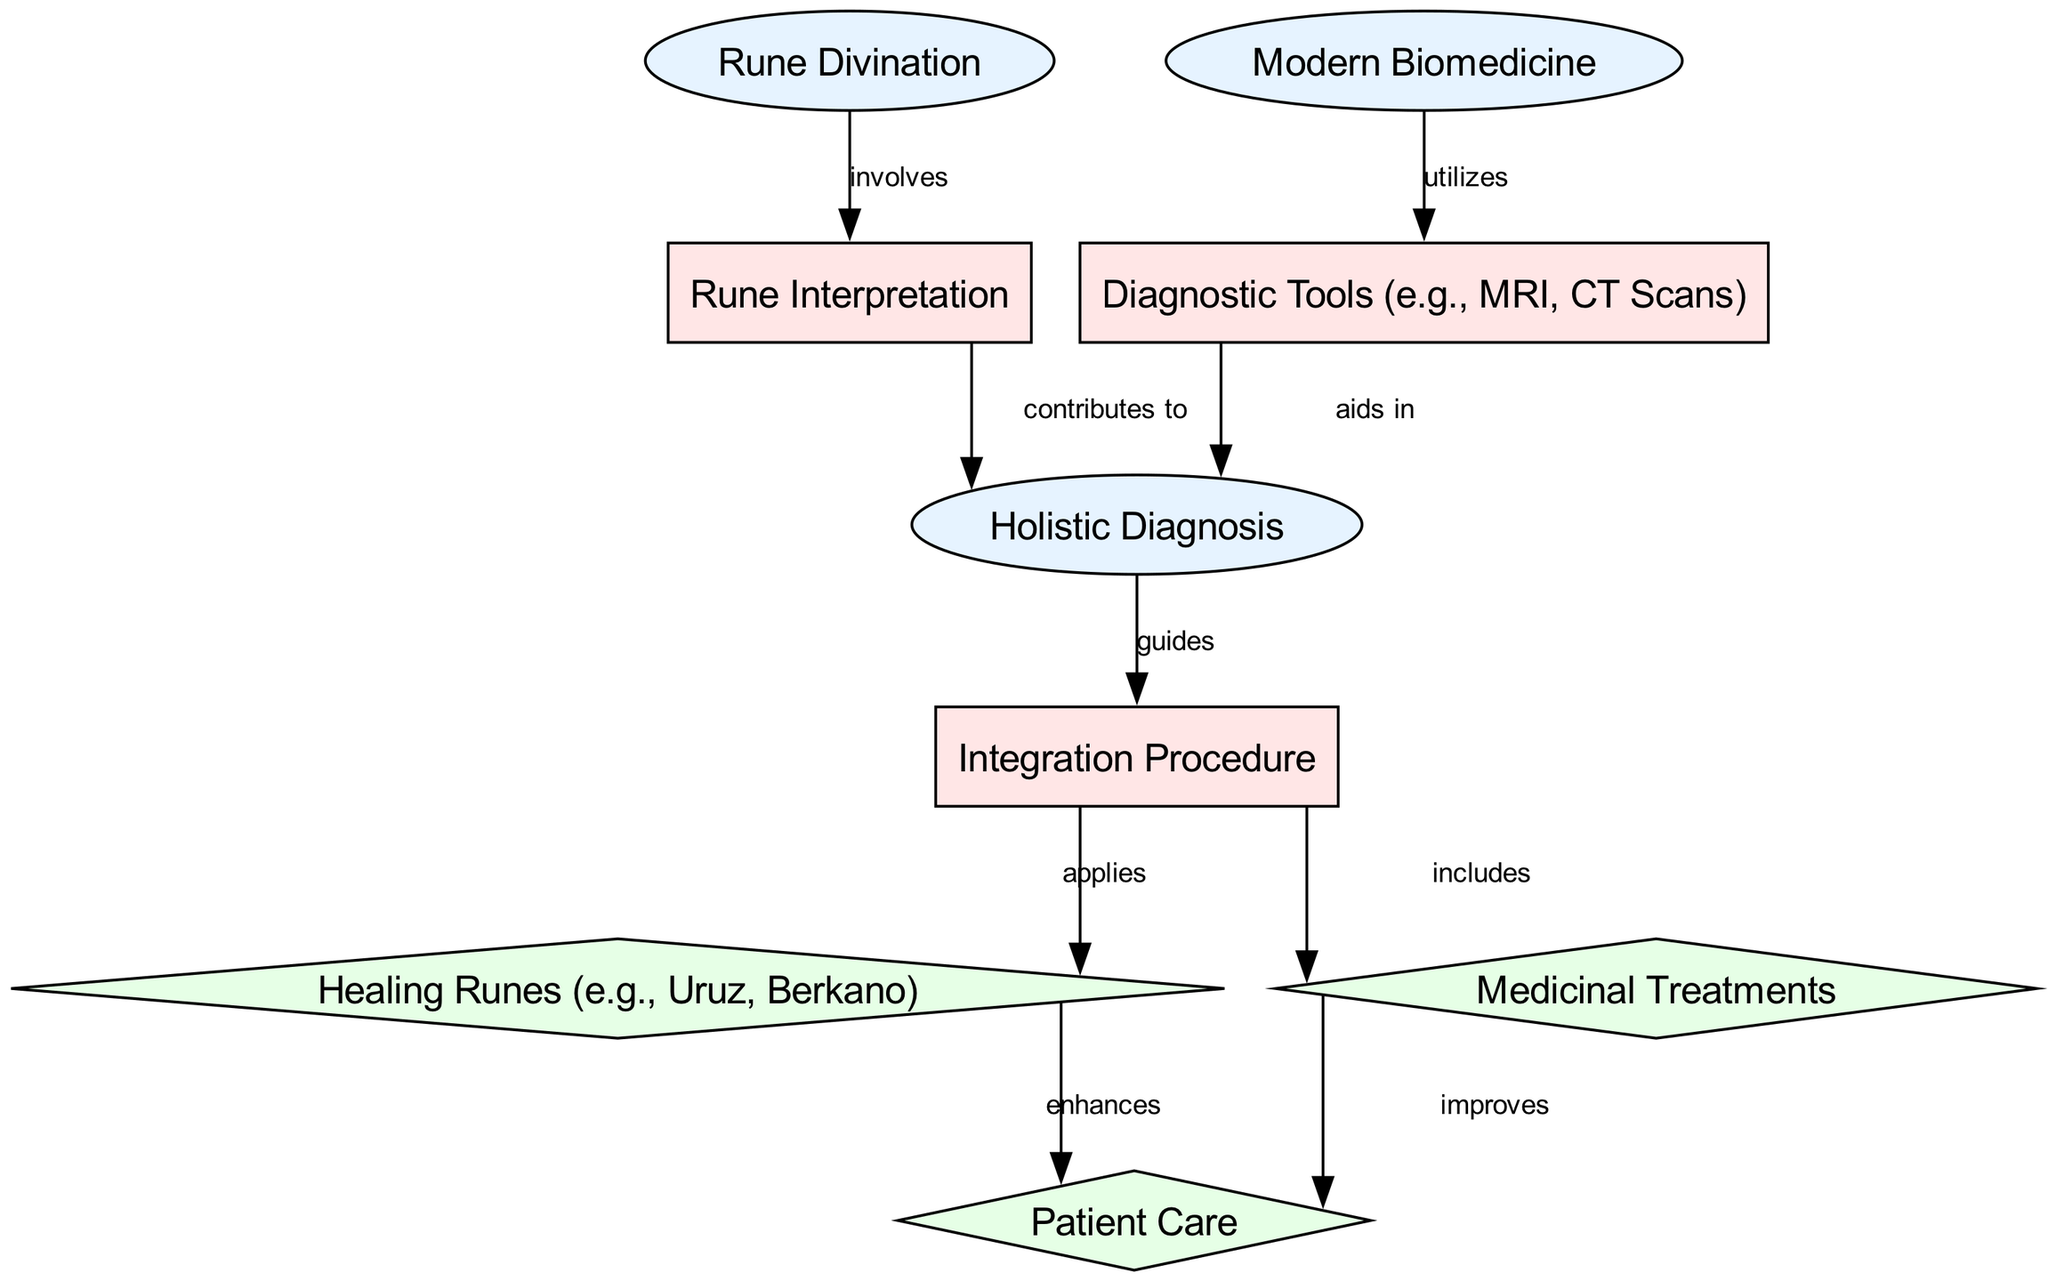What is the first process listed in the diagram? The first process in the diagram is 'Rune Interpretation', which is directly connected to 'Rune Divination'. We identify this by assessing the flow from the initial node connected by the edge labeled "involves".
Answer: Rune Interpretation How many outcomes are shown in the diagram? There are three outcomes depicted in the diagram: 'Healing Runes', 'Medicinal Treatments', and 'Patient Care'. We arrive at this count by identifying and tallying the nodes classified as outcomes.
Answer: 3 What type of relationship exists between 'Holistic Diagnosis' and 'Integration Procedure'? The relationship is that 'Holistic Diagnosis' guides the 'Integration Procedure'. This is indicated by the edge labeled "guides" connecting these two nodes, showing a direct influence.
Answer: guides Which two nodes contribute to 'Holistic Diagnosis'? 'Rune Interpretation' and 'Diagnostic Tools' contribute to 'Holistic Diagnosis' as per the edges labeled "contributes to" and "aids in", respectively. This indicates that both processes feed into the holistic approach to diagnosis.
Answer: Rune Interpretation, Diagnostic Tools What is the outcome of applying 'Healing Runes'? The outcome of applying 'Healing Runes' is 'Patient Care', as indicated by the edge labeled "enhances" connecting these two nodes. This shows that the use of healing runes positively impacts patient care.
Answer: Patient Care How does 'Integration Procedure' influence patient care? 'Integration Procedure' influences patient care by including 'Medicinal Treatments' and applying 'Healing Runes'. This means that the integration process incorporates both modalities to improve the outcomes for patients.
Answer: improves, enhances What does 'Modern Biomedicine' utilize? 'Modern Biomedicine' utilizes 'Diagnostic Tools (e.g., MRI, CT Scans)', as noted by the edge labeled "utilizes". This shows the dependency of modern biomedical practices on diagnostic technologies for evaluation and treatment plans.
Answer: Diagnostic Tools (e.g., MRI, CT Scans) What is the connection between 'healing runes' and 'medicinal treatments'? The connection is that both are outcomes of the 'Integration Procedure', meaning they are separate but parallel paths that result from the integration of modern techniques with rune-derived healing practices.
Answer: Integration Procedure 